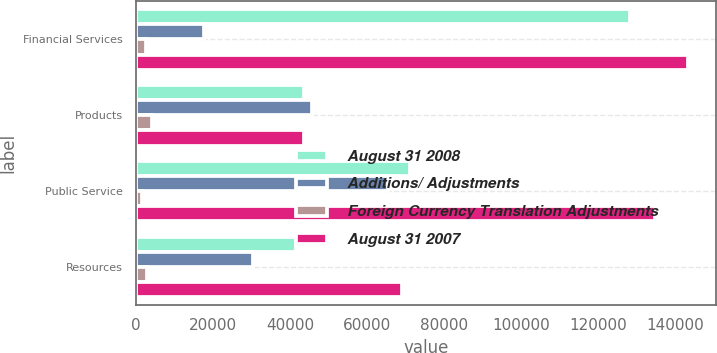<chart> <loc_0><loc_0><loc_500><loc_500><stacked_bar_chart><ecel><fcel>Financial Services<fcel>Products<fcel>Public Service<fcel>Resources<nl><fcel>August 31 2008<fcel>128343<fcel>43590<fcel>71211<fcel>41401<nl><fcel>Additions/ Adjustments<fcel>17727<fcel>45779<fcel>65324<fcel>30286<nl><fcel>Foreign Currency Translation Adjustments<fcel>2690<fcel>4023<fcel>1640<fcel>2723<nl><fcel>August 31 2007<fcel>143380<fcel>43590<fcel>134895<fcel>68964<nl></chart> 